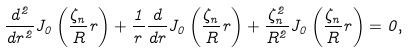<formula> <loc_0><loc_0><loc_500><loc_500>\frac { d ^ { 2 } } { d r ^ { 2 } } J _ { 0 } \left ( \frac { \zeta _ { n } } { R } r \right ) + \frac { 1 } { r } \frac { d } { d r } J _ { 0 } \left ( \frac { \zeta _ { n } } { R } r \right ) + \frac { \zeta _ { n } ^ { 2 } } { R ^ { 2 } } J _ { 0 } \left ( \frac { \zeta _ { n } } { R } r \right ) = 0 ,</formula> 